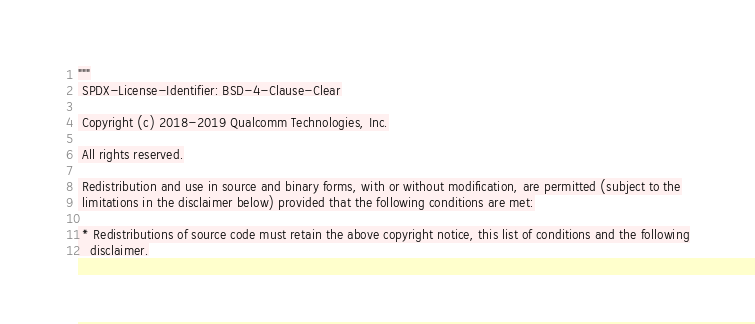Convert code to text. <code><loc_0><loc_0><loc_500><loc_500><_Python_>"""
 SPDX-License-Identifier: BSD-4-Clause-Clear

 Copyright (c) 2018-2019 Qualcomm Technologies, Inc.

 All rights reserved.

 Redistribution and use in source and binary forms, with or without modification, are permitted (subject to the
 limitations in the disclaimer below) provided that the following conditions are met:

 * Redistributions of source code must retain the above copyright notice, this list of conditions and the following
   disclaimer.</code> 